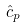Convert formula to latex. <formula><loc_0><loc_0><loc_500><loc_500>\hat { c } _ { p }</formula> 